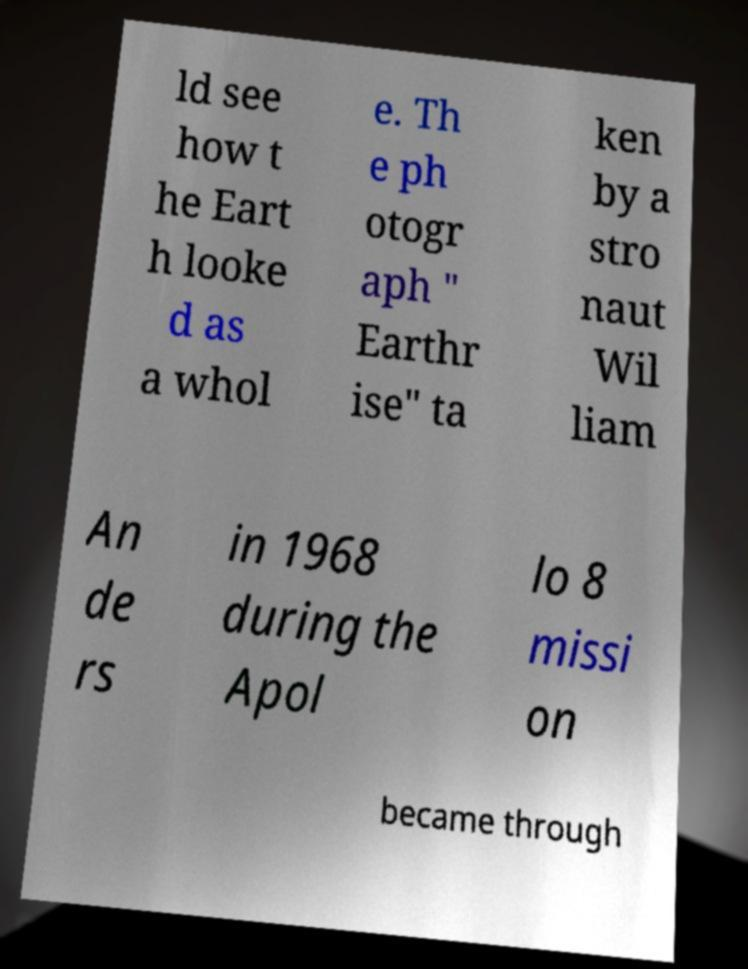Please identify and transcribe the text found in this image. ld see how t he Eart h looke d as a whol e. Th e ph otogr aph " Earthr ise" ta ken by a stro naut Wil liam An de rs in 1968 during the Apol lo 8 missi on became through 